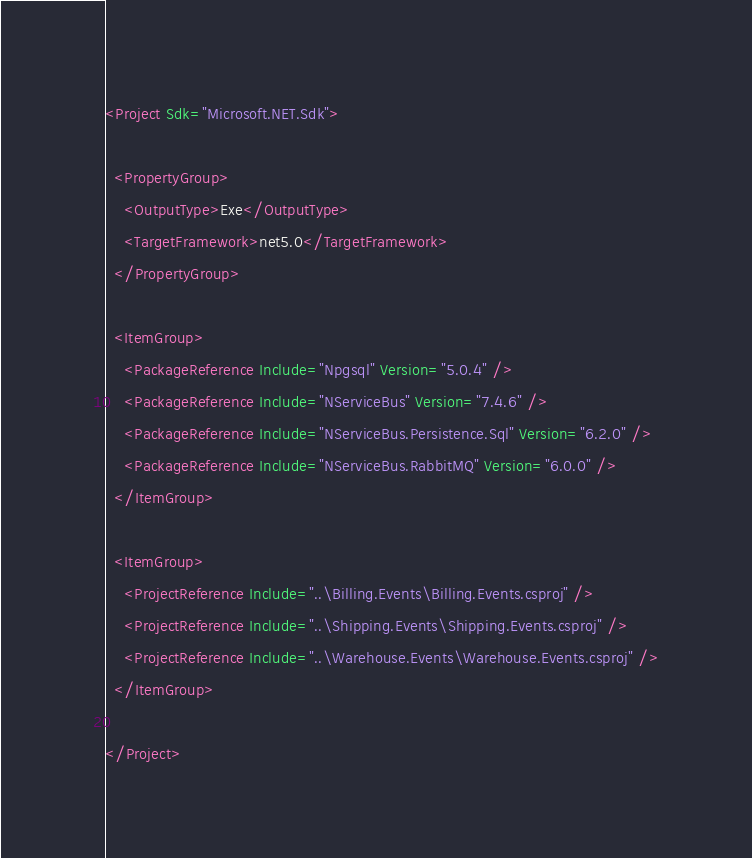<code> <loc_0><loc_0><loc_500><loc_500><_XML_><Project Sdk="Microsoft.NET.Sdk">

  <PropertyGroup>
    <OutputType>Exe</OutputType>
    <TargetFramework>net5.0</TargetFramework>
  </PropertyGroup>

  <ItemGroup>
    <PackageReference Include="Npgsql" Version="5.0.4" />
    <PackageReference Include="NServiceBus" Version="7.4.6" />
    <PackageReference Include="NServiceBus.Persistence.Sql" Version="6.2.0" />
    <PackageReference Include="NServiceBus.RabbitMQ" Version="6.0.0" />
  </ItemGroup>

  <ItemGroup>
    <ProjectReference Include="..\Billing.Events\Billing.Events.csproj" />
    <ProjectReference Include="..\Shipping.Events\Shipping.Events.csproj" />
    <ProjectReference Include="..\Warehouse.Events\Warehouse.Events.csproj" />
  </ItemGroup>

</Project>
</code> 